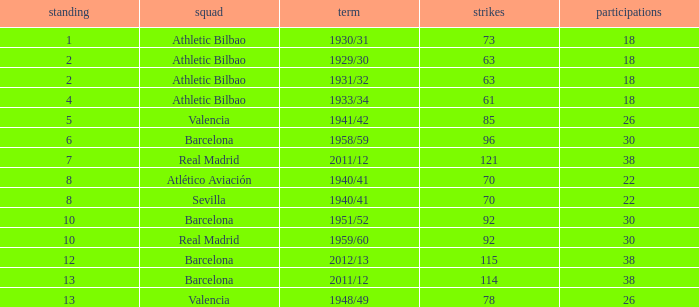Who was the club having less than 22 apps and ranked less than 2? Athletic Bilbao. 